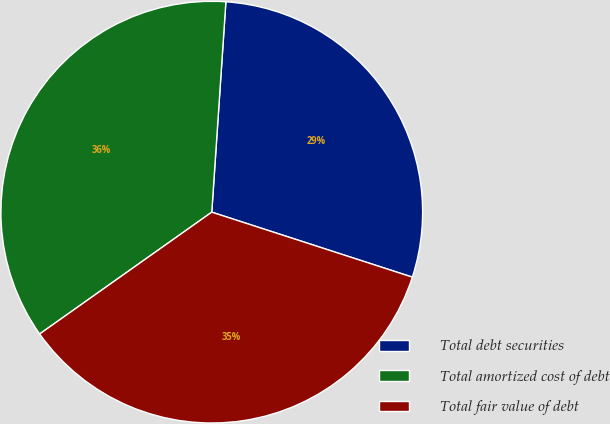Convert chart. <chart><loc_0><loc_0><loc_500><loc_500><pie_chart><fcel>Total debt securities<fcel>Total amortized cost of debt<fcel>Total fair value of debt<nl><fcel>28.92%<fcel>35.87%<fcel>35.21%<nl></chart> 